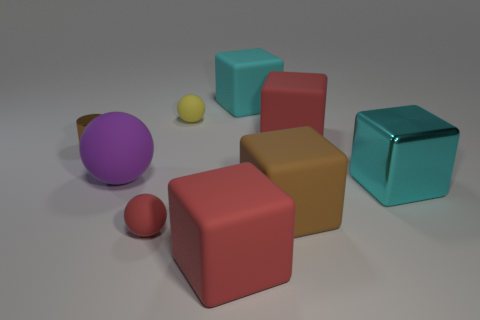Subtract all cyan balls. How many red cubes are left? 2 Subtract 3 cubes. How many cubes are left? 2 Subtract all brown cubes. How many cubes are left? 4 Subtract all cyan metal blocks. How many blocks are left? 4 Add 1 brown rubber things. How many objects exist? 10 Subtract all blue cubes. Subtract all gray spheres. How many cubes are left? 5 Subtract all blocks. How many objects are left? 4 Subtract 0 gray cylinders. How many objects are left? 9 Subtract all tiny red objects. Subtract all matte things. How many objects are left? 1 Add 9 small red rubber objects. How many small red rubber objects are left? 10 